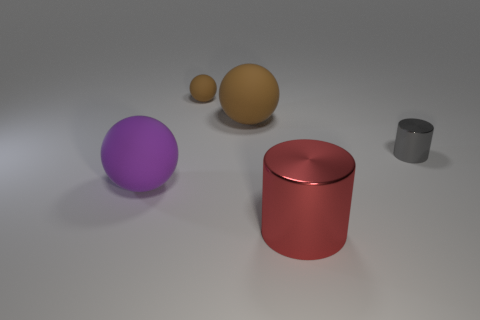Subtract all large rubber balls. How many balls are left? 1 Add 4 tiny brown things. How many objects exist? 9 Subtract all purple spheres. How many spheres are left? 2 Subtract all cylinders. How many objects are left? 3 Subtract all yellow cubes. How many purple balls are left? 1 Add 2 red metal cylinders. How many red metal cylinders are left? 3 Add 4 big purple rubber spheres. How many big purple rubber spheres exist? 5 Subtract 0 yellow cubes. How many objects are left? 5 Subtract 1 cylinders. How many cylinders are left? 1 Subtract all cyan cylinders. Subtract all brown blocks. How many cylinders are left? 2 